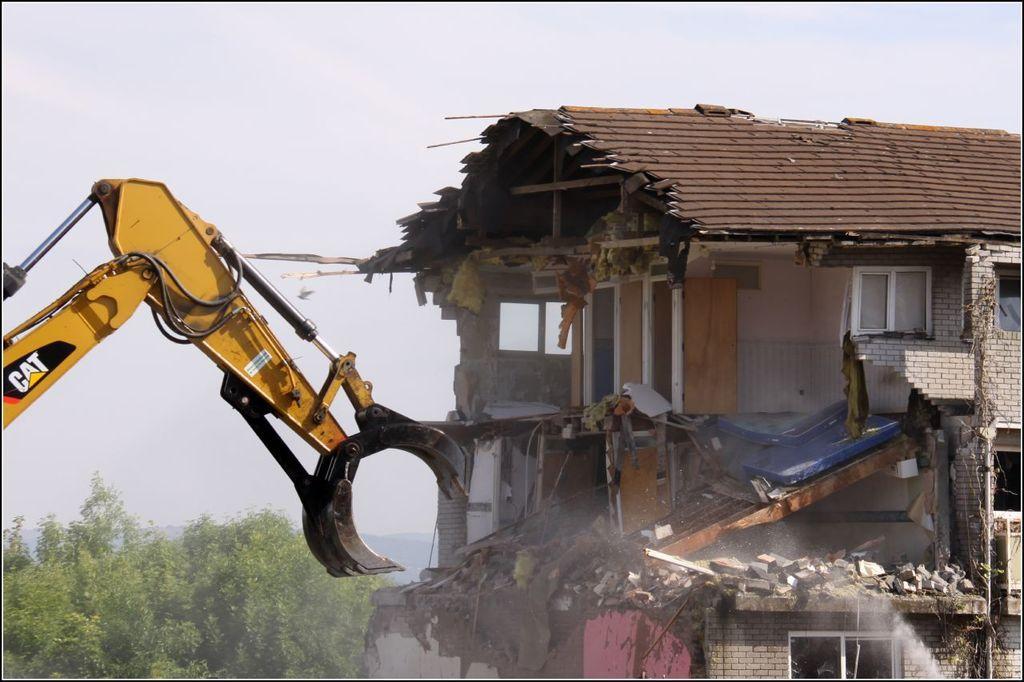In one or two sentences, can you explain what this image depicts? This image consists of a crane. To the right, there is a building. To the left, there are trees. At the top, there is a sky. 